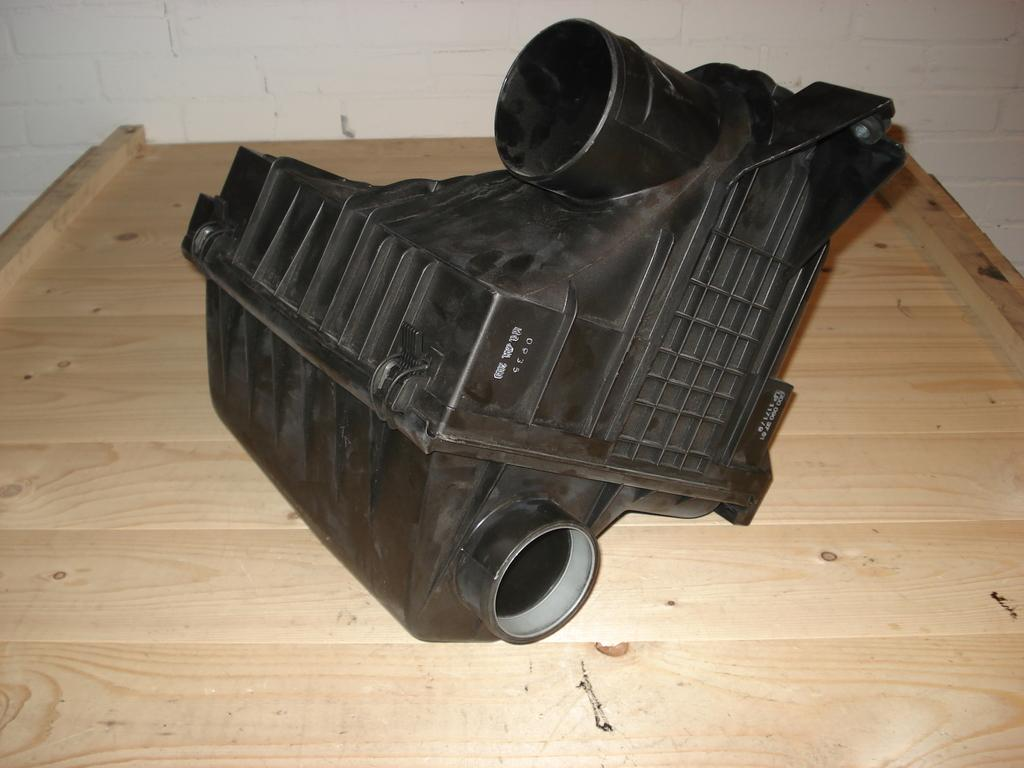What type of material is the table in the image made of? The table in the image is made of wood. What is placed on the wooden table? There is a plastic item on the wooden table. What can be seen in the background of the image? There is a wall in the background of the image. What time of day is it in the image, considering the presence of a yak? There is no yak present in the image, so it is not possible to determine the time of day based on that information. 